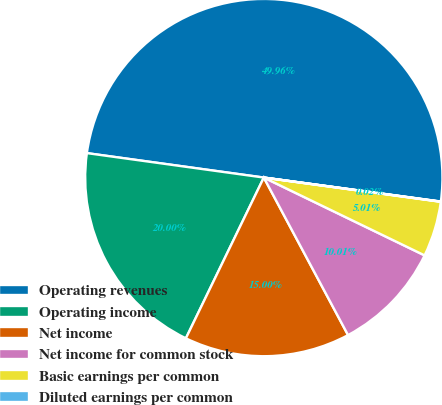<chart> <loc_0><loc_0><loc_500><loc_500><pie_chart><fcel>Operating revenues<fcel>Operating income<fcel>Net income<fcel>Net income for common stock<fcel>Basic earnings per common<fcel>Diluted earnings per common<nl><fcel>49.96%<fcel>20.0%<fcel>15.0%<fcel>10.01%<fcel>5.01%<fcel>0.02%<nl></chart> 